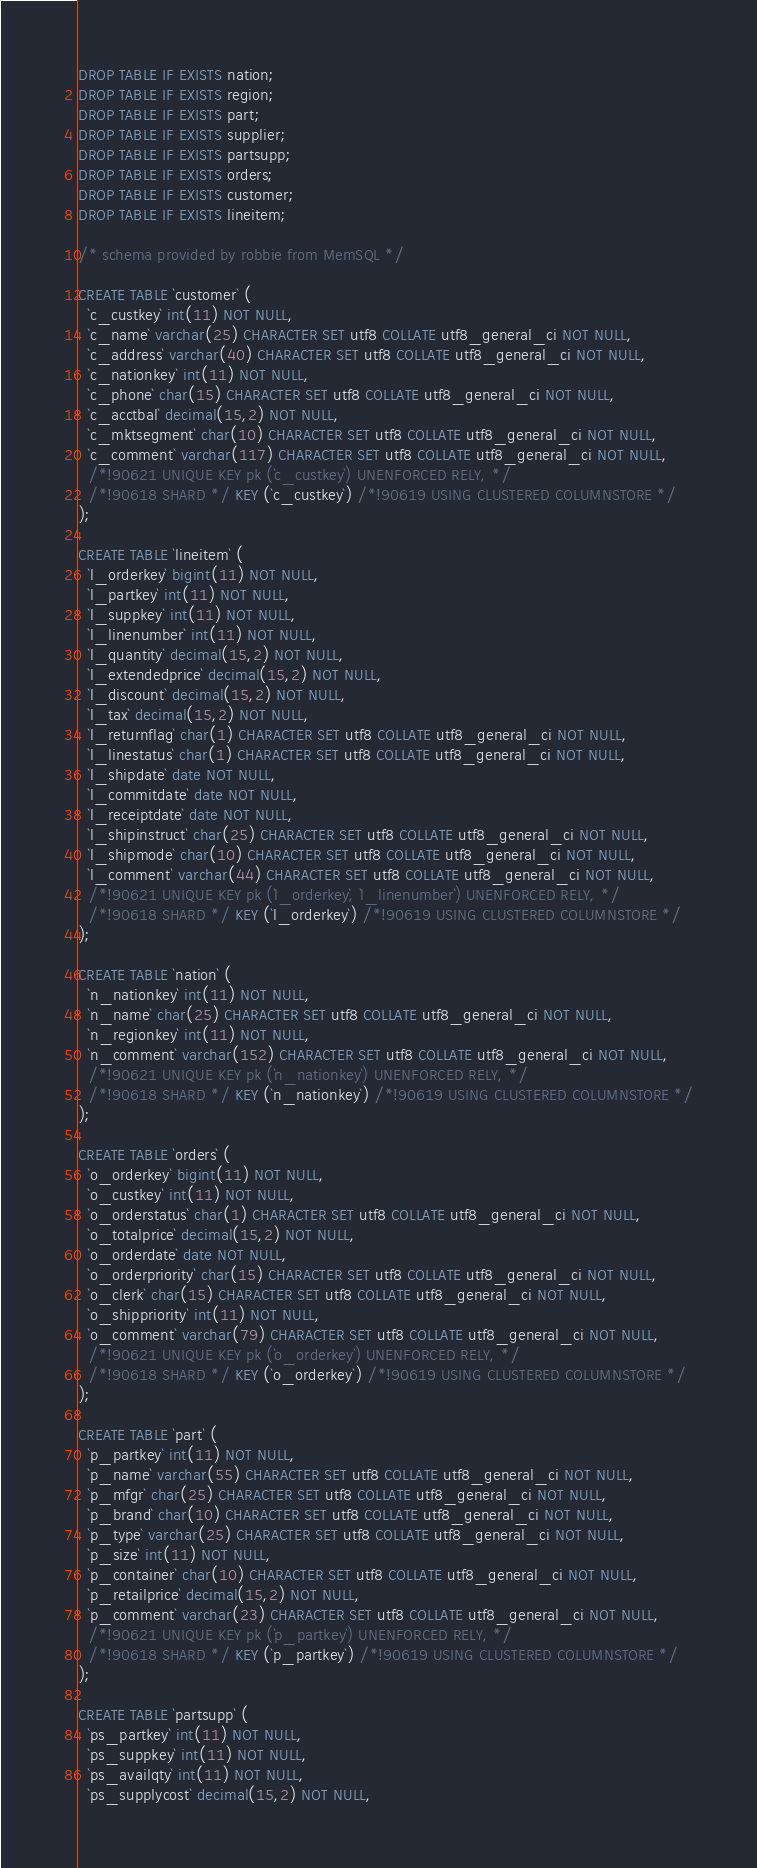Convert code to text. <code><loc_0><loc_0><loc_500><loc_500><_SQL_>DROP TABLE IF EXISTS nation;
DROP TABLE IF EXISTS region;
DROP TABLE IF EXISTS part;
DROP TABLE IF EXISTS supplier;
DROP TABLE IF EXISTS partsupp;
DROP TABLE IF EXISTS orders;
DROP TABLE IF EXISTS customer;
DROP TABLE IF EXISTS lineitem;

/* schema provided by robbie from MemSQL */

CREATE TABLE `customer` (
  `c_custkey` int(11) NOT NULL,
  `c_name` varchar(25) CHARACTER SET utf8 COLLATE utf8_general_ci NOT NULL,
  `c_address` varchar(40) CHARACTER SET utf8 COLLATE utf8_general_ci NOT NULL,
  `c_nationkey` int(11) NOT NULL,
  `c_phone` char(15) CHARACTER SET utf8 COLLATE utf8_general_ci NOT NULL,
  `c_acctbal` decimal(15,2) NOT NULL,
  `c_mktsegment` char(10) CHARACTER SET utf8 COLLATE utf8_general_ci NOT NULL,
  `c_comment` varchar(117) CHARACTER SET utf8 COLLATE utf8_general_ci NOT NULL,
  /*!90621 UNIQUE KEY pk (`c_custkey`) UNENFORCED RELY, */
  /*!90618 SHARD */ KEY (`c_custkey`) /*!90619 USING CLUSTERED COLUMNSTORE */
);

CREATE TABLE `lineitem` (
  `l_orderkey` bigint(11) NOT NULL,
  `l_partkey` int(11) NOT NULL,
  `l_suppkey` int(11) NOT NULL,
  `l_linenumber` int(11) NOT NULL,
  `l_quantity` decimal(15,2) NOT NULL,
  `l_extendedprice` decimal(15,2) NOT NULL,
  `l_discount` decimal(15,2) NOT NULL,
  `l_tax` decimal(15,2) NOT NULL,
  `l_returnflag` char(1) CHARACTER SET utf8 COLLATE utf8_general_ci NOT NULL,
  `l_linestatus` char(1) CHARACTER SET utf8 COLLATE utf8_general_ci NOT NULL,
  `l_shipdate` date NOT NULL,
  `l_commitdate` date NOT NULL,
  `l_receiptdate` date NOT NULL,
  `l_shipinstruct` char(25) CHARACTER SET utf8 COLLATE utf8_general_ci NOT NULL,
  `l_shipmode` char(10) CHARACTER SET utf8 COLLATE utf8_general_ci NOT NULL,
  `l_comment` varchar(44) CHARACTER SET utf8 COLLATE utf8_general_ci NOT NULL,
  /*!90621 UNIQUE KEY pk (`l_orderkey`, `l_linenumber`) UNENFORCED RELY, */
  /*!90618 SHARD */ KEY (`l_orderkey`) /*!90619 USING CLUSTERED COLUMNSTORE */
);

CREATE TABLE `nation` (
  `n_nationkey` int(11) NOT NULL,
  `n_name` char(25) CHARACTER SET utf8 COLLATE utf8_general_ci NOT NULL,
  `n_regionkey` int(11) NOT NULL,
  `n_comment` varchar(152) CHARACTER SET utf8 COLLATE utf8_general_ci NOT NULL,
  /*!90621 UNIQUE KEY pk (`n_nationkey`) UNENFORCED RELY, */
  /*!90618 SHARD */ KEY (`n_nationkey`) /*!90619 USING CLUSTERED COLUMNSTORE */
);

CREATE TABLE `orders` (
  `o_orderkey` bigint(11) NOT NULL,
  `o_custkey` int(11) NOT NULL,
  `o_orderstatus` char(1) CHARACTER SET utf8 COLLATE utf8_general_ci NOT NULL,
  `o_totalprice` decimal(15,2) NOT NULL,
  `o_orderdate` date NOT NULL,
  `o_orderpriority` char(15) CHARACTER SET utf8 COLLATE utf8_general_ci NOT NULL,
  `o_clerk` char(15) CHARACTER SET utf8 COLLATE utf8_general_ci NOT NULL,
  `o_shippriority` int(11) NOT NULL,
  `o_comment` varchar(79) CHARACTER SET utf8 COLLATE utf8_general_ci NOT NULL,
  /*!90621 UNIQUE KEY pk (`o_orderkey`) UNENFORCED RELY, */
  /*!90618 SHARD */ KEY (`o_orderkey`) /*!90619 USING CLUSTERED COLUMNSTORE */
);

CREATE TABLE `part` (
  `p_partkey` int(11) NOT NULL,
  `p_name` varchar(55) CHARACTER SET utf8 COLLATE utf8_general_ci NOT NULL,
  `p_mfgr` char(25) CHARACTER SET utf8 COLLATE utf8_general_ci NOT NULL,
  `p_brand` char(10) CHARACTER SET utf8 COLLATE utf8_general_ci NOT NULL,
  `p_type` varchar(25) CHARACTER SET utf8 COLLATE utf8_general_ci NOT NULL,
  `p_size` int(11) NOT NULL,
  `p_container` char(10) CHARACTER SET utf8 COLLATE utf8_general_ci NOT NULL,
  `p_retailprice` decimal(15,2) NOT NULL,
  `p_comment` varchar(23) CHARACTER SET utf8 COLLATE utf8_general_ci NOT NULL,
  /*!90621 UNIQUE KEY pk (`p_partkey`) UNENFORCED RELY, */
  /*!90618 SHARD */ KEY (`p_partkey`) /*!90619 USING CLUSTERED COLUMNSTORE */
);

CREATE TABLE `partsupp` (
  `ps_partkey` int(11) NOT NULL,
  `ps_suppkey` int(11) NOT NULL,
  `ps_availqty` int(11) NOT NULL,
  `ps_supplycost` decimal(15,2) NOT NULL,</code> 